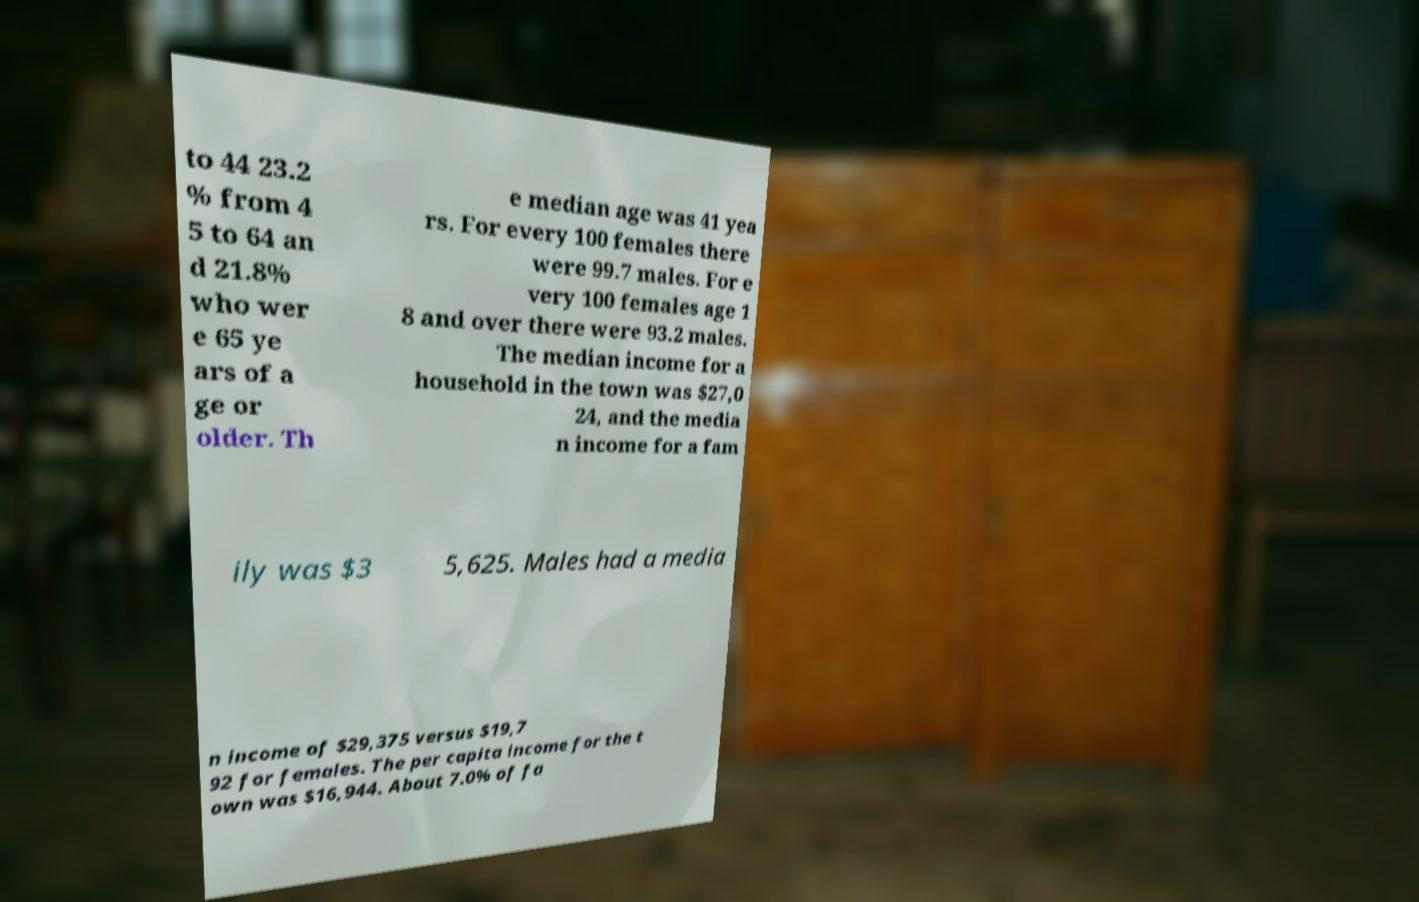Can you accurately transcribe the text from the provided image for me? to 44 23.2 % from 4 5 to 64 an d 21.8% who wer e 65 ye ars of a ge or older. Th e median age was 41 yea rs. For every 100 females there were 99.7 males. For e very 100 females age 1 8 and over there were 93.2 males. The median income for a household in the town was $27,0 24, and the media n income for a fam ily was $3 5,625. Males had a media n income of $29,375 versus $19,7 92 for females. The per capita income for the t own was $16,944. About 7.0% of fa 